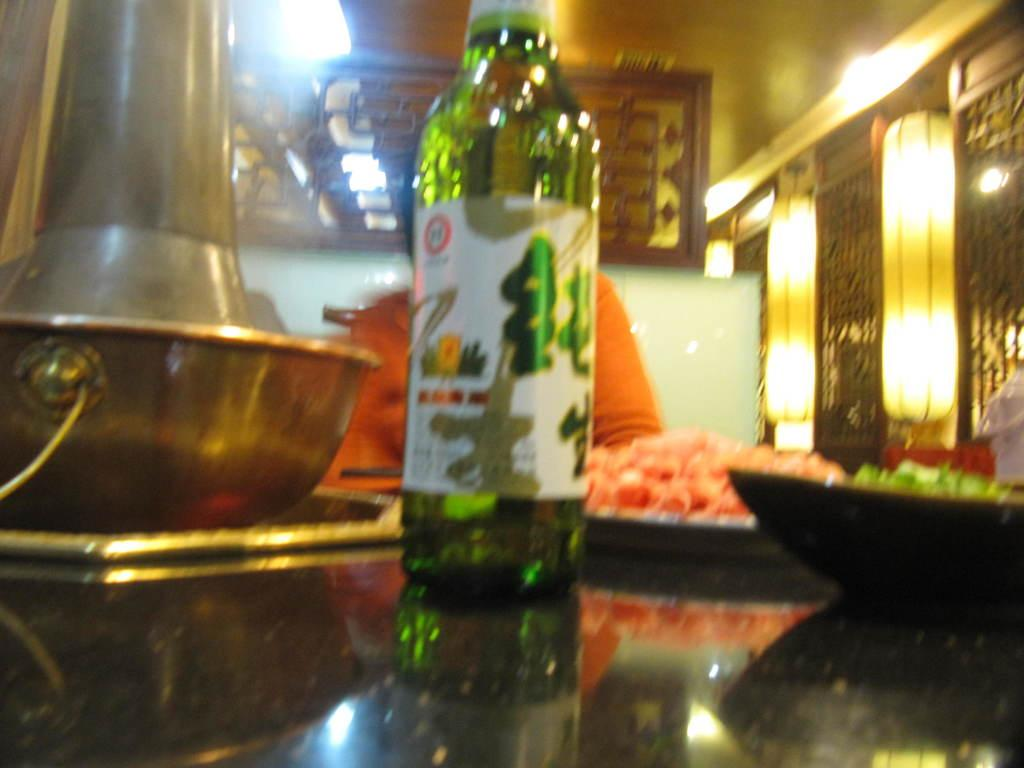What object can be seen in the image that is typically used for holding liquids? There is a glass bottle in the image. What is located on top of the table in the image? There are food eatables on top of a table. What type of decorative items can be seen in the background of the image? There are designed photo frames in the background. What is visible behind the photo frames in the image? There is a wall visible in the background. Reasoning: Let's think step by step by following the facts step by step to create the conversation. We start by identifying the main object in the image, which is the glass bottle. Then, we describe the food items on the table and the decorative photo frames in the background. Finally, we mention the wall visible behind the photo frames. Each question is designed to focus on a specific detail about the image that can be answered definitively with the given facts. Absurd Question/Answer: What type of feather can be seen floating in the air in the image? There is no feather visible in the image. What type of weather can be inferred from the image? The image does not provide any information about the weather. 